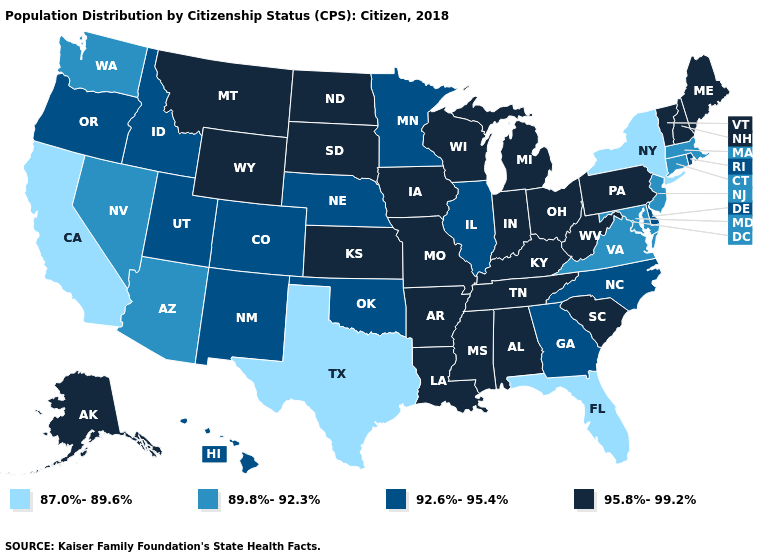Does the map have missing data?
Short answer required. No. Does Illinois have the highest value in the USA?
Write a very short answer. No. Which states hav the highest value in the Northeast?
Give a very brief answer. Maine, New Hampshire, Pennsylvania, Vermont. Name the states that have a value in the range 92.6%-95.4%?
Write a very short answer. Colorado, Delaware, Georgia, Hawaii, Idaho, Illinois, Minnesota, Nebraska, New Mexico, North Carolina, Oklahoma, Oregon, Rhode Island, Utah. Name the states that have a value in the range 95.8%-99.2%?
Keep it brief. Alabama, Alaska, Arkansas, Indiana, Iowa, Kansas, Kentucky, Louisiana, Maine, Michigan, Mississippi, Missouri, Montana, New Hampshire, North Dakota, Ohio, Pennsylvania, South Carolina, South Dakota, Tennessee, Vermont, West Virginia, Wisconsin, Wyoming. Does Massachusetts have the highest value in the Northeast?
Write a very short answer. No. What is the value of Florida?
Keep it brief. 87.0%-89.6%. Name the states that have a value in the range 92.6%-95.4%?
Keep it brief. Colorado, Delaware, Georgia, Hawaii, Idaho, Illinois, Minnesota, Nebraska, New Mexico, North Carolina, Oklahoma, Oregon, Rhode Island, Utah. What is the value of South Dakota?
Be succinct. 95.8%-99.2%. Does Illinois have the highest value in the MidWest?
Keep it brief. No. Does Tennessee have the highest value in the USA?
Give a very brief answer. Yes. Name the states that have a value in the range 87.0%-89.6%?
Quick response, please. California, Florida, New York, Texas. Name the states that have a value in the range 87.0%-89.6%?
Quick response, please. California, Florida, New York, Texas. What is the value of Washington?
Be succinct. 89.8%-92.3%. What is the lowest value in states that border Arizona?
Short answer required. 87.0%-89.6%. 